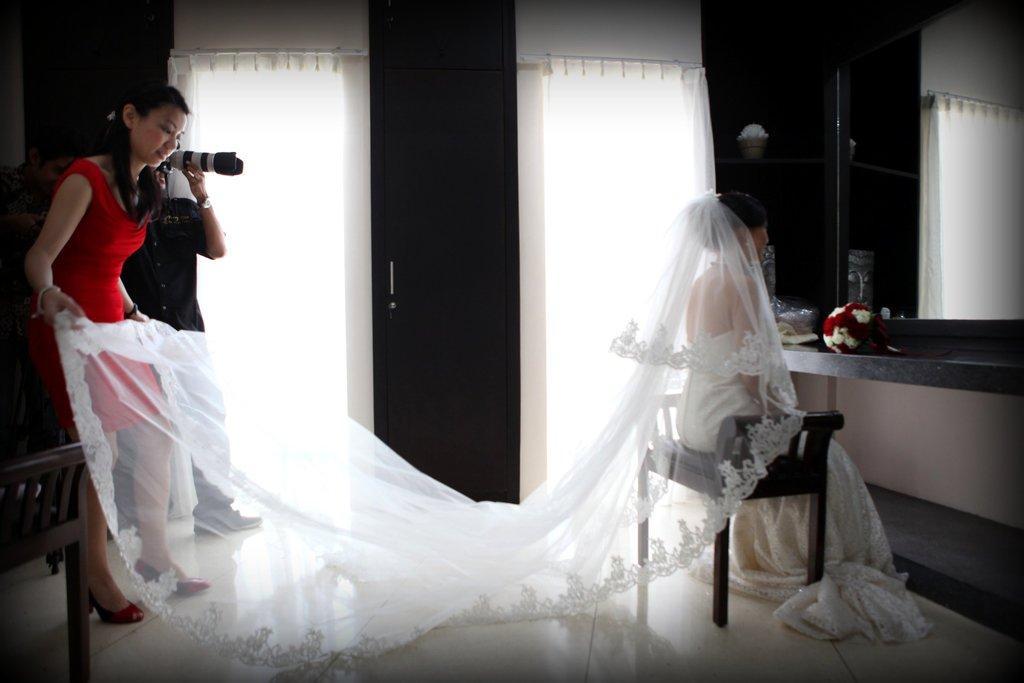Please provide a concise description of this image. In this picture we can see two persons are standing on the left side, on the right side there is a woman sitting on a chair, there is a flower bouquet in front of her, a person in the background is holding a camera, on the left side there is another chair, in the background we can see curtains, there is a mirror on the right side. 